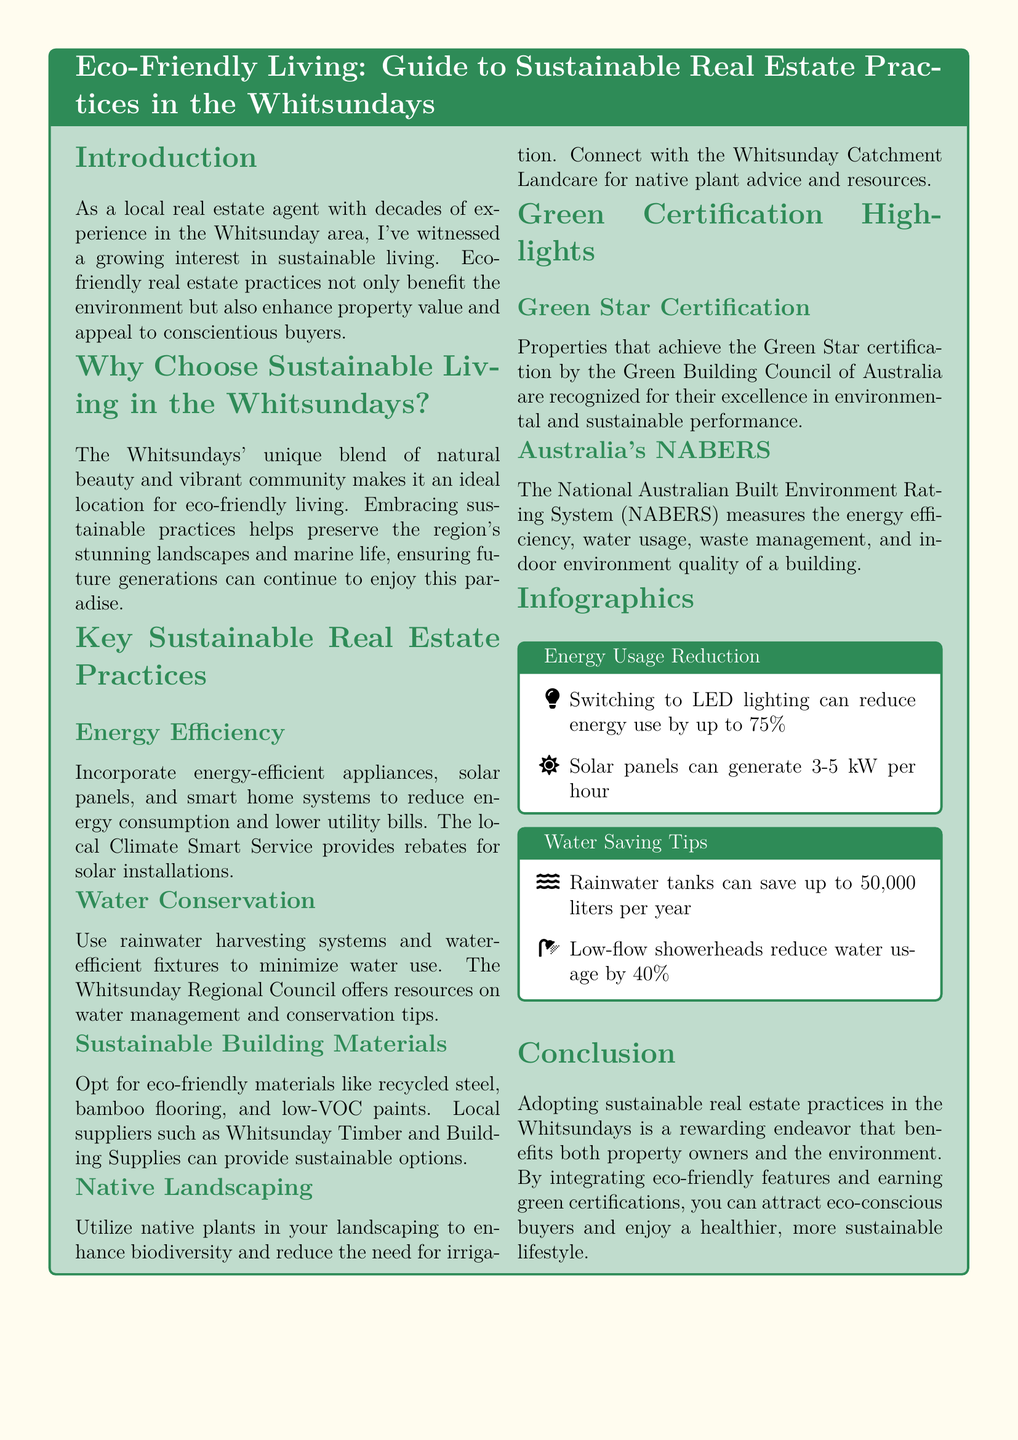what is the title of the guide? The title of the guide is mentioned in the tcolorbox, reflecting the document's main subject.
Answer: Eco-Friendly Living: Guide to Sustainable Real Estate Practices in the Whitsundays what are two benefits of eco-friendly real estate practices? The document outlines benefits including environmental protection and enhanced property value, showing the dual advantage of sustainable practices.
Answer: Environmental protection, enhanced property value which organization offers rebates for solar installations? The organization providing rebates is explicitly noted in the energy efficiency section of the document, identifying local support for sustainable practices.
Answer: Climate Smart Service how much can rainwater tanks save annually? The water saving tips section states the annual savings provided by rainwater tanks, indicating a potential impact on water conservation.
Answer: 50,000 liters what type of certification is awarded by the Green Building Council of Australia? The specific certification awarded for excellence in environmental performance is directly cited, indicating recognition of sustainable building practices.
Answer: Green Star certification how much can switching to LED lighting reduce energy use? This figure is highlighted in the infographic section, providing specific data on energy efficiency benefits of lighting choices.
Answer: 75 percent what is the purpose of Australia's NABERS? The purpose of NABERS is explained in the green certification highlights, indicating its relevance to assessing building efficiency.
Answer: Measures energy efficiency, water usage, waste management, and indoor environment quality which local supplier offers eco-friendly materials? The suppliers of sustainable building materials are listed providing specific local options available to homeowners.
Answer: Whitsunday Timber and Building Supplies what is the color of the document's background? The background color is explicitly described in the document, which contributes to its visual appeal.
Answer: Sandy yellow 